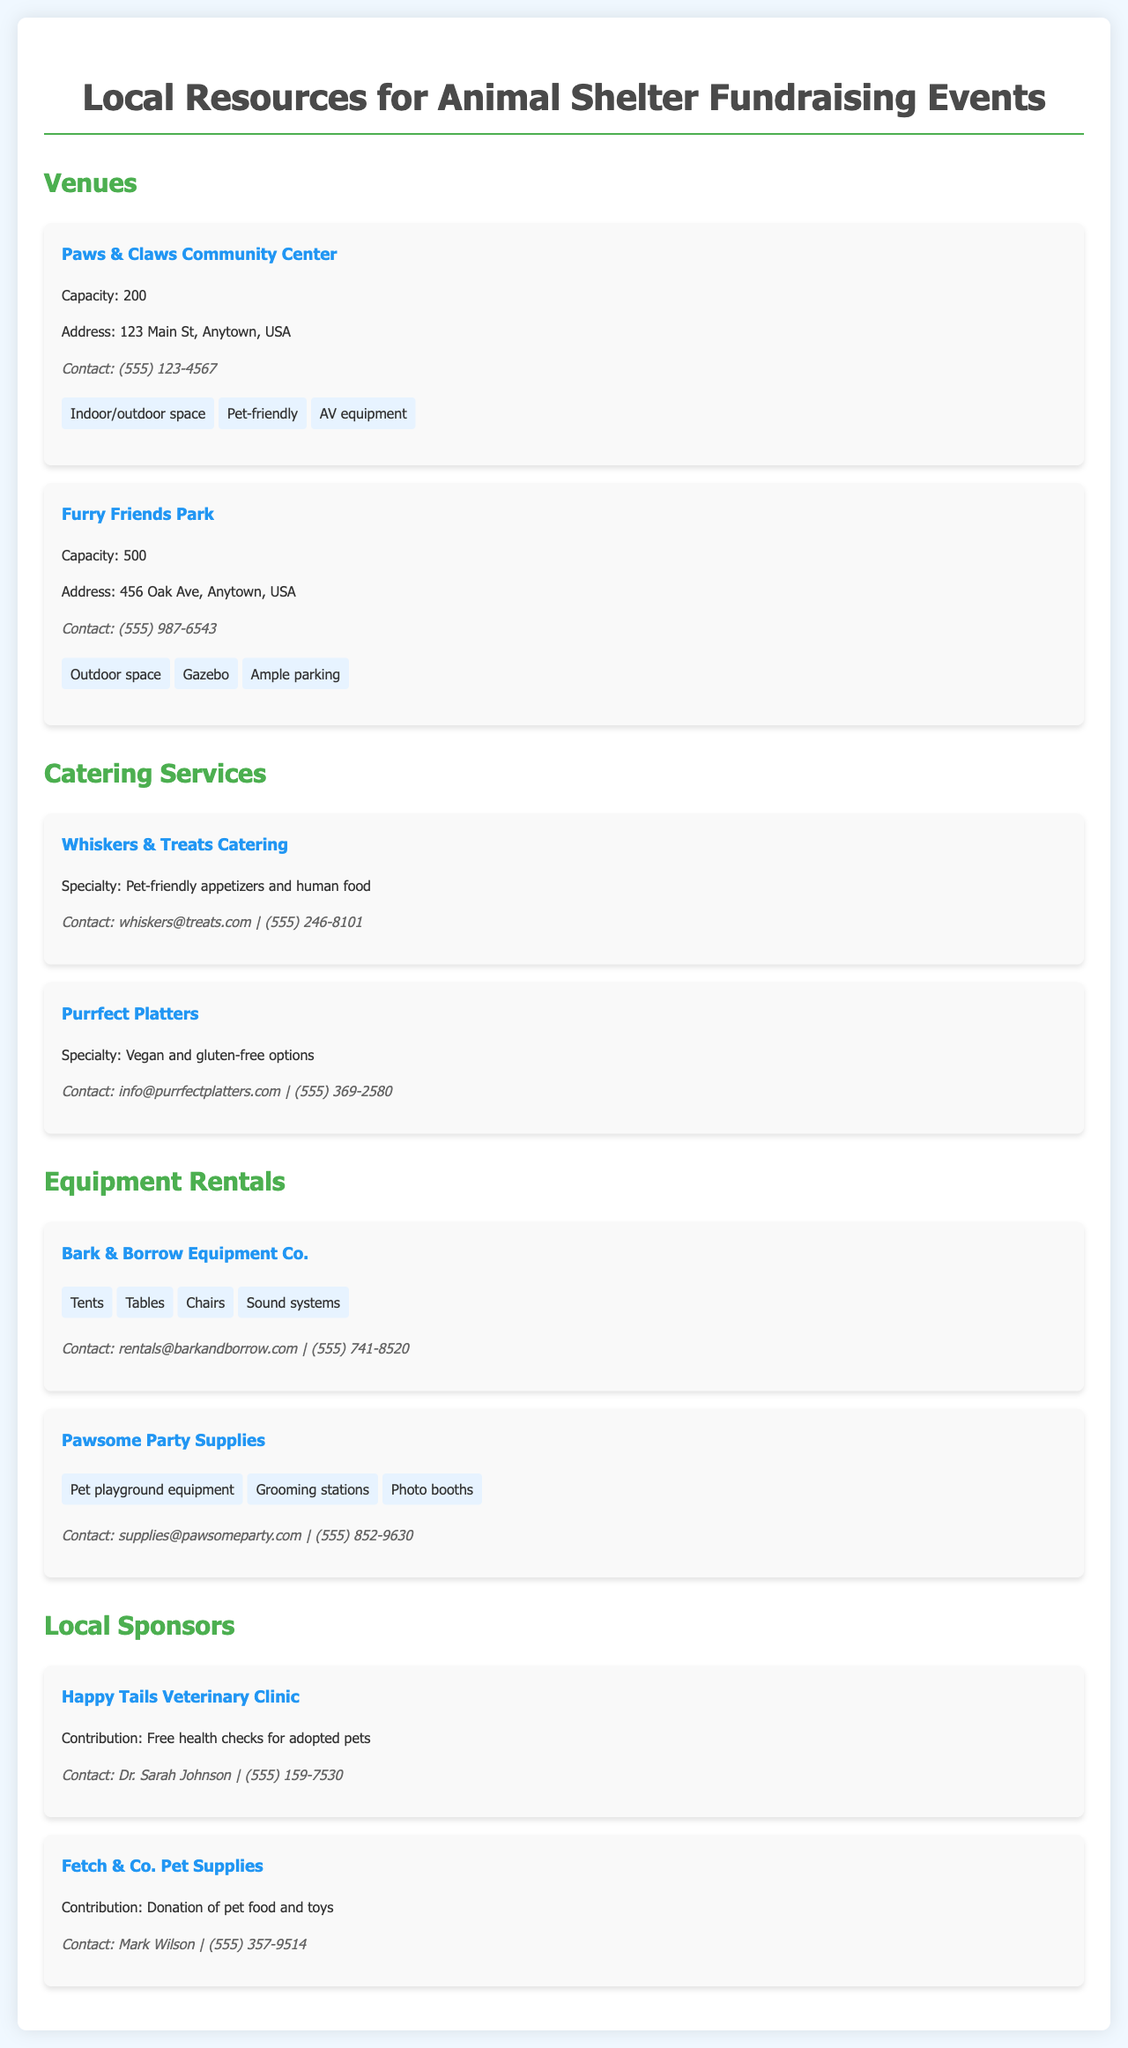What is the capacity of Paws & Claws Community Center? The capacity of Paws & Claws Community Center is stated in the document as 200.
Answer: 200 What is the address of Furry Friends Park? The address of Furry Friends Park is provided in the document as 456 Oak Ave, Anytown, USA.
Answer: 456 Oak Ave, Anytown, USA What type of food does Whiskers & Treats Catering specialize in? The document specifies that Whiskers & Treats Catering specializes in pet-friendly appetizers and human food.
Answer: Pet-friendly appetizers and human food How many items are listed under Bark & Borrow Equipment Co.? The document lists four items provided by Bark & Borrow Equipment Co.: Tents, Tables, Chairs, and Sound systems.
Answer: 4 Which local sponsor offers free health checks for adopted pets? The document mentions Happy Tails Veterinary Clinic as the local sponsor offering free health checks.
Answer: Happy Tails Veterinary Clinic What unique feature does Furry Friends Park provide? Furry Friends Park provides a gazebo as a unique feature.
Answer: Gazebo What contact information is given for Pawsome Party Supplies? The contact information for Pawsome Party Supplies is found in the document as supplies@pawsomeparty.com
Answer: supplies@pawsomeparty.com List one item available for rent from Pawsome Party Supplies. The document contains items such as pet playground equipment, grooming stations, and photo booths available from Pawsome Party Supplies.
Answer: Pet playground equipment 